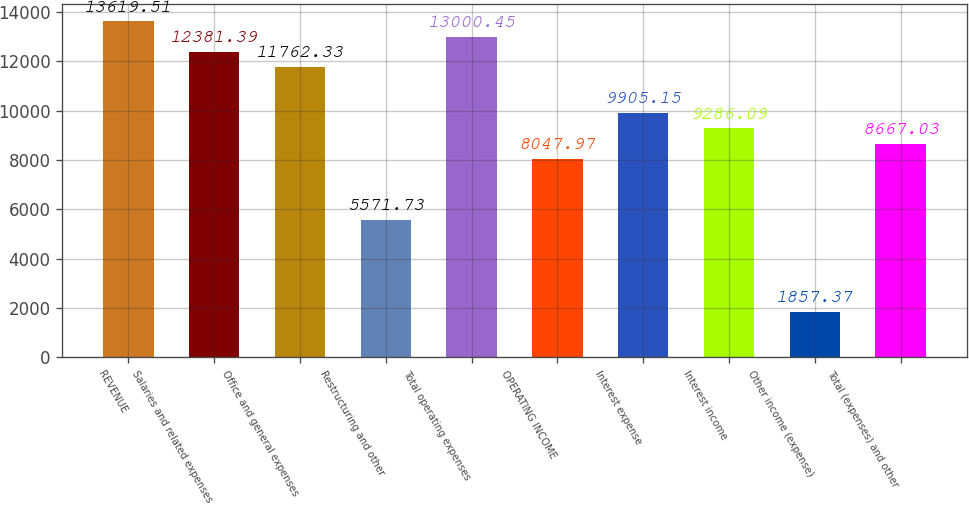Convert chart. <chart><loc_0><loc_0><loc_500><loc_500><bar_chart><fcel>REVENUE<fcel>Salaries and related expenses<fcel>Office and general expenses<fcel>Restructuring and other<fcel>Total operating expenses<fcel>OPERATING INCOME<fcel>Interest expense<fcel>Interest income<fcel>Other income (expense)<fcel>Total (expenses) and other<nl><fcel>13619.5<fcel>12381.4<fcel>11762.3<fcel>5571.73<fcel>13000.5<fcel>8047.97<fcel>9905.15<fcel>9286.09<fcel>1857.37<fcel>8667.03<nl></chart> 